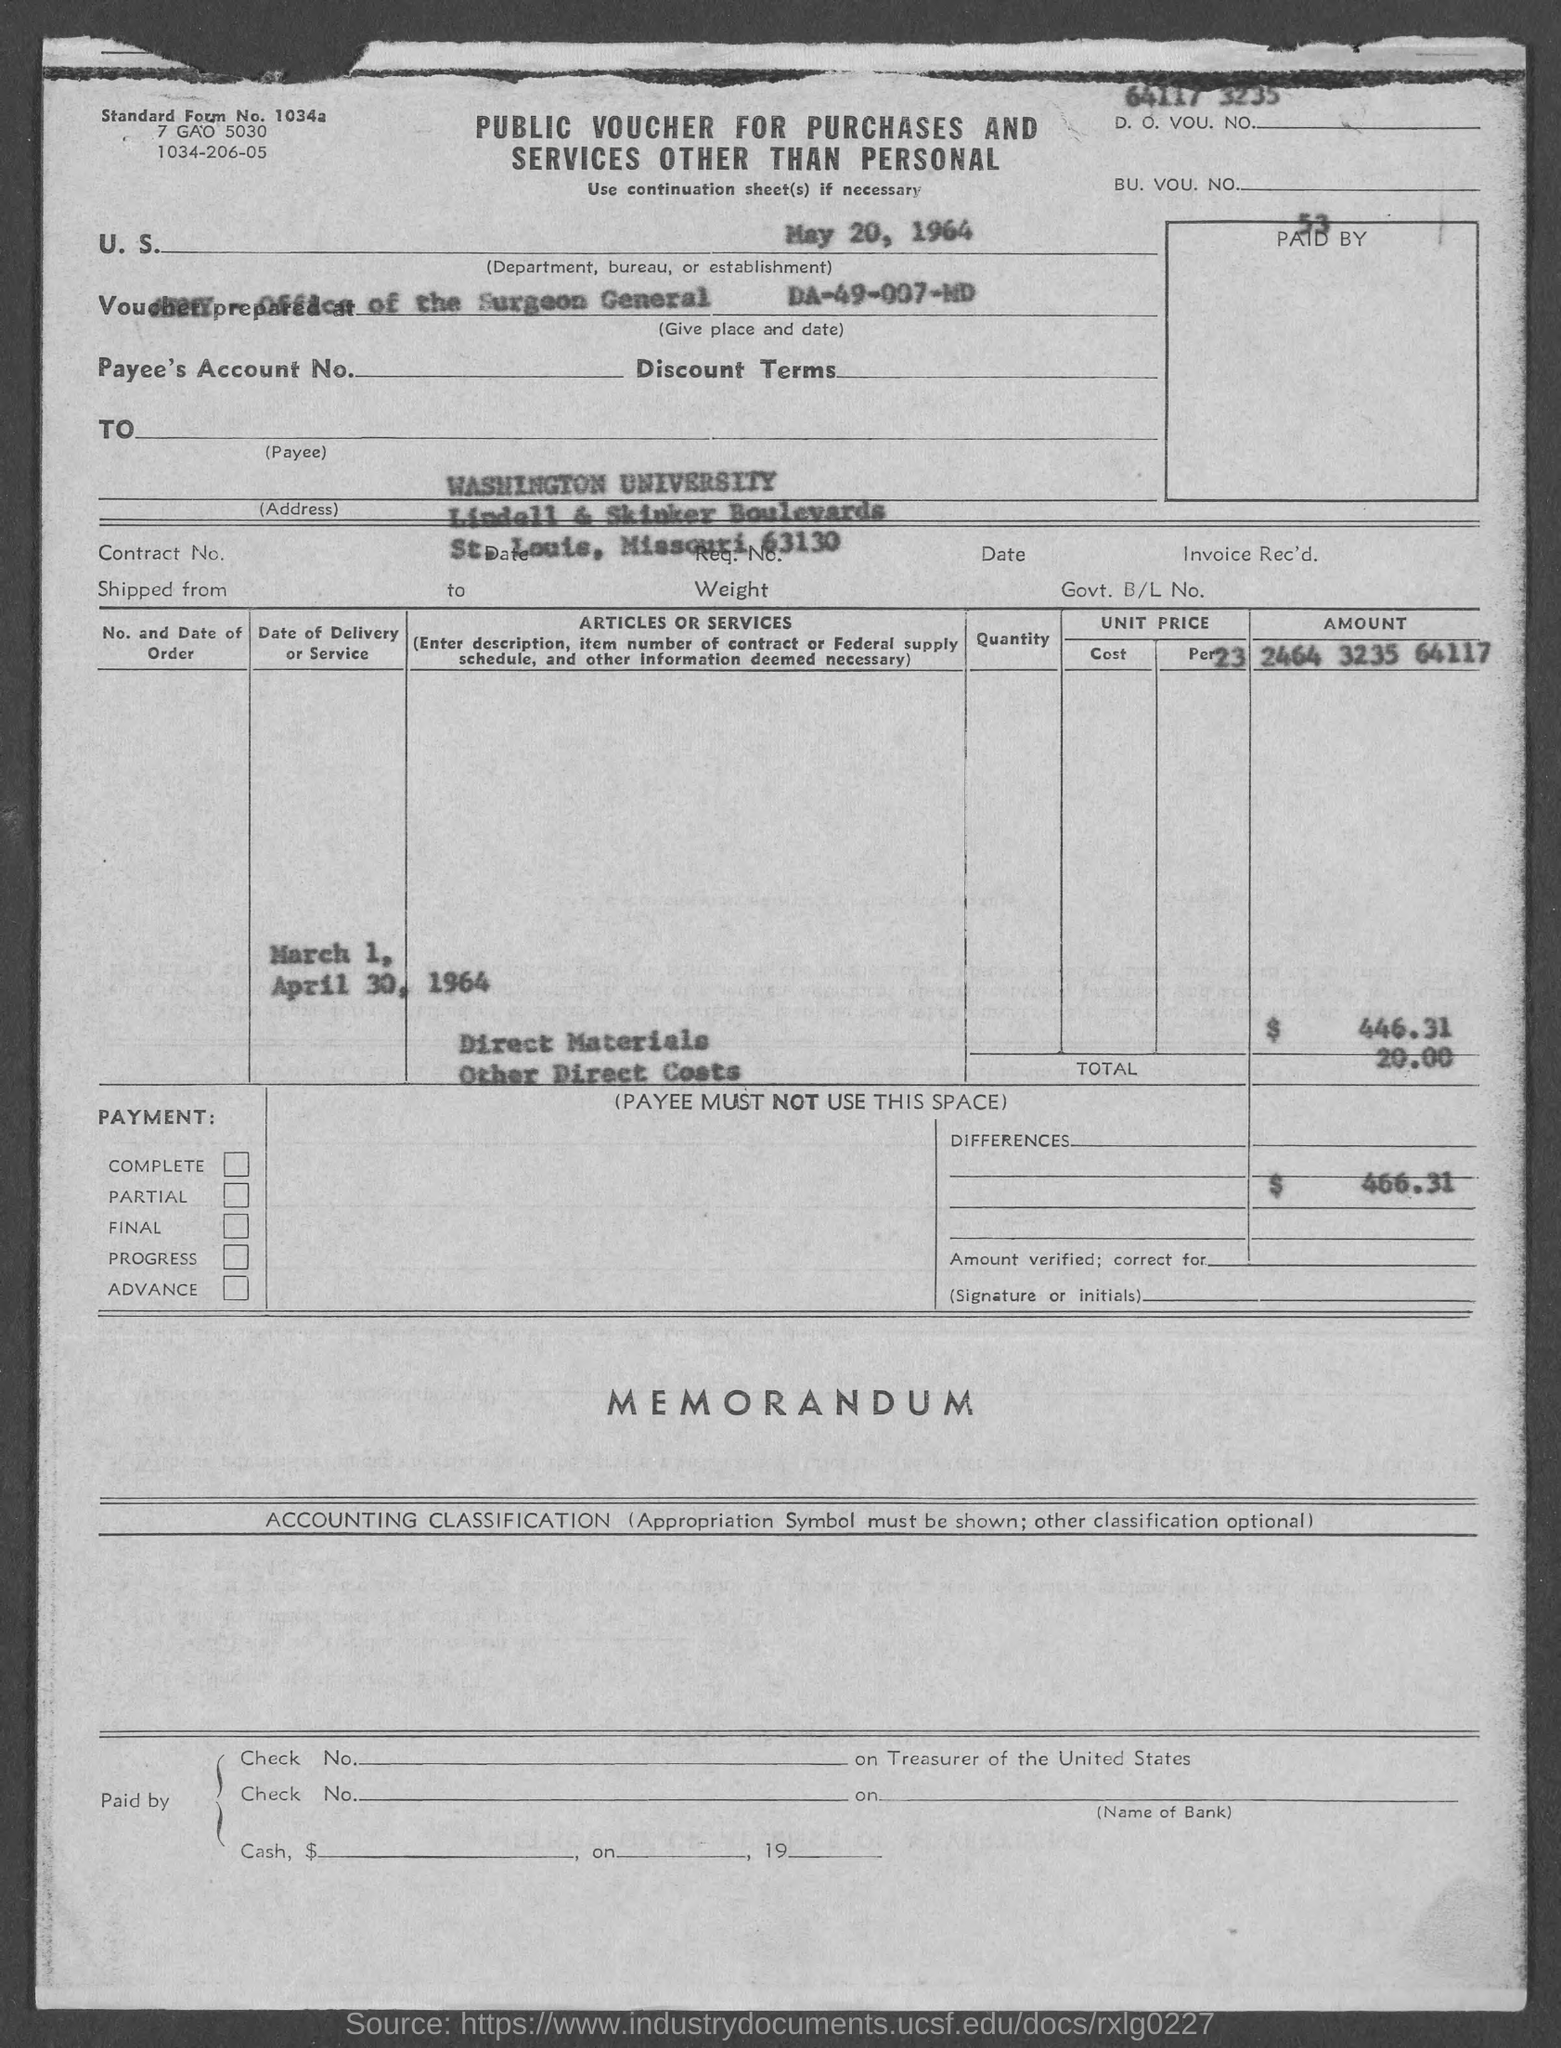What is the standard form no.?
Provide a succinct answer. 1034a. 